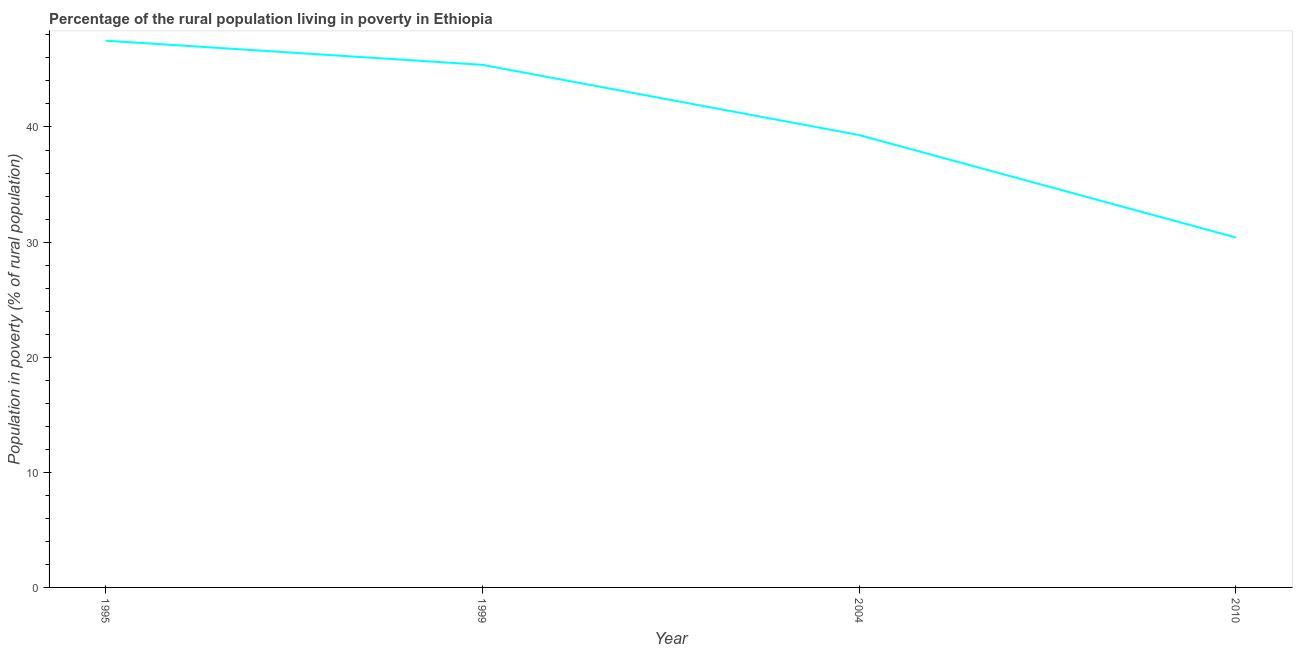What is the percentage of rural population living below poverty line in 2010?
Ensure brevity in your answer.  30.4. Across all years, what is the maximum percentage of rural population living below poverty line?
Ensure brevity in your answer.  47.5. Across all years, what is the minimum percentage of rural population living below poverty line?
Provide a short and direct response. 30.4. In which year was the percentage of rural population living below poverty line minimum?
Provide a short and direct response. 2010. What is the sum of the percentage of rural population living below poverty line?
Make the answer very short. 162.6. What is the difference between the percentage of rural population living below poverty line in 1995 and 2010?
Offer a terse response. 17.1. What is the average percentage of rural population living below poverty line per year?
Ensure brevity in your answer.  40.65. What is the median percentage of rural population living below poverty line?
Your answer should be compact. 42.35. In how many years, is the percentage of rural population living below poverty line greater than 4 %?
Make the answer very short. 4. Do a majority of the years between 1995 and 1999 (inclusive) have percentage of rural population living below poverty line greater than 38 %?
Make the answer very short. Yes. What is the ratio of the percentage of rural population living below poverty line in 1995 to that in 1999?
Your answer should be compact. 1.05. Is the percentage of rural population living below poverty line in 1995 less than that in 1999?
Offer a very short reply. No. Is the difference between the percentage of rural population living below poverty line in 1995 and 2010 greater than the difference between any two years?
Provide a succinct answer. Yes. What is the difference between the highest and the second highest percentage of rural population living below poverty line?
Your response must be concise. 2.1. Is the sum of the percentage of rural population living below poverty line in 1995 and 2010 greater than the maximum percentage of rural population living below poverty line across all years?
Your answer should be very brief. Yes. How many lines are there?
Provide a short and direct response. 1. What is the difference between two consecutive major ticks on the Y-axis?
Offer a terse response. 10. Does the graph contain any zero values?
Your response must be concise. No. Does the graph contain grids?
Give a very brief answer. No. What is the title of the graph?
Offer a very short reply. Percentage of the rural population living in poverty in Ethiopia. What is the label or title of the X-axis?
Your answer should be compact. Year. What is the label or title of the Y-axis?
Provide a succinct answer. Population in poverty (% of rural population). What is the Population in poverty (% of rural population) of 1995?
Ensure brevity in your answer.  47.5. What is the Population in poverty (% of rural population) of 1999?
Keep it short and to the point. 45.4. What is the Population in poverty (% of rural population) of 2004?
Make the answer very short. 39.3. What is the Population in poverty (% of rural population) of 2010?
Give a very brief answer. 30.4. What is the difference between the Population in poverty (% of rural population) in 1995 and 2010?
Your answer should be very brief. 17.1. What is the difference between the Population in poverty (% of rural population) in 1999 and 2004?
Your answer should be compact. 6.1. What is the difference between the Population in poverty (% of rural population) in 1999 and 2010?
Provide a short and direct response. 15. What is the ratio of the Population in poverty (% of rural population) in 1995 to that in 1999?
Offer a very short reply. 1.05. What is the ratio of the Population in poverty (% of rural population) in 1995 to that in 2004?
Offer a very short reply. 1.21. What is the ratio of the Population in poverty (% of rural population) in 1995 to that in 2010?
Your answer should be compact. 1.56. What is the ratio of the Population in poverty (% of rural population) in 1999 to that in 2004?
Ensure brevity in your answer.  1.16. What is the ratio of the Population in poverty (% of rural population) in 1999 to that in 2010?
Your answer should be compact. 1.49. What is the ratio of the Population in poverty (% of rural population) in 2004 to that in 2010?
Offer a terse response. 1.29. 